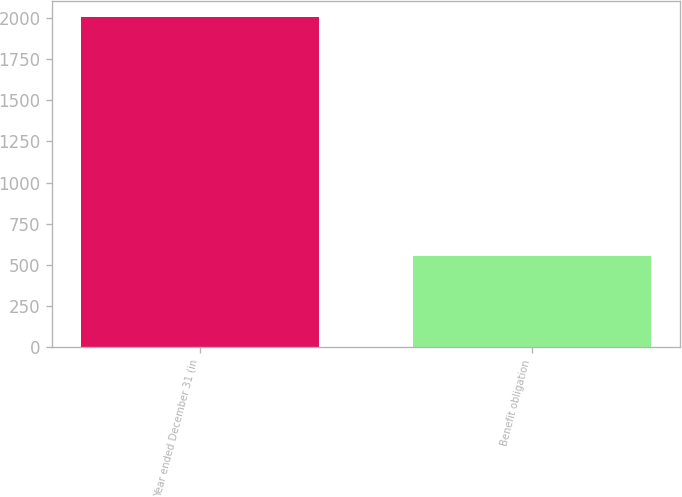<chart> <loc_0><loc_0><loc_500><loc_500><bar_chart><fcel>Year ended December 31 (in<fcel>Benefit obligation<nl><fcel>2006<fcel>554<nl></chart> 